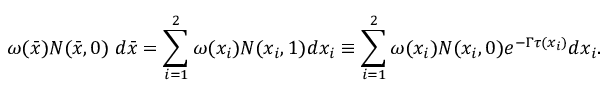<formula> <loc_0><loc_0><loc_500><loc_500>\omega ( \bar { x } ) N ( \bar { x } , 0 ) \, d \bar { x } = \sum _ { i = 1 } ^ { 2 } \omega ( x _ { i } ) N ( x _ { i } , 1 ) d x _ { i } \equiv \sum _ { i = 1 } ^ { 2 } \omega ( x _ { i } ) N ( x _ { i } , 0 ) e ^ { - \Gamma \tau ( x _ { i } ) } d x _ { i } .</formula> 